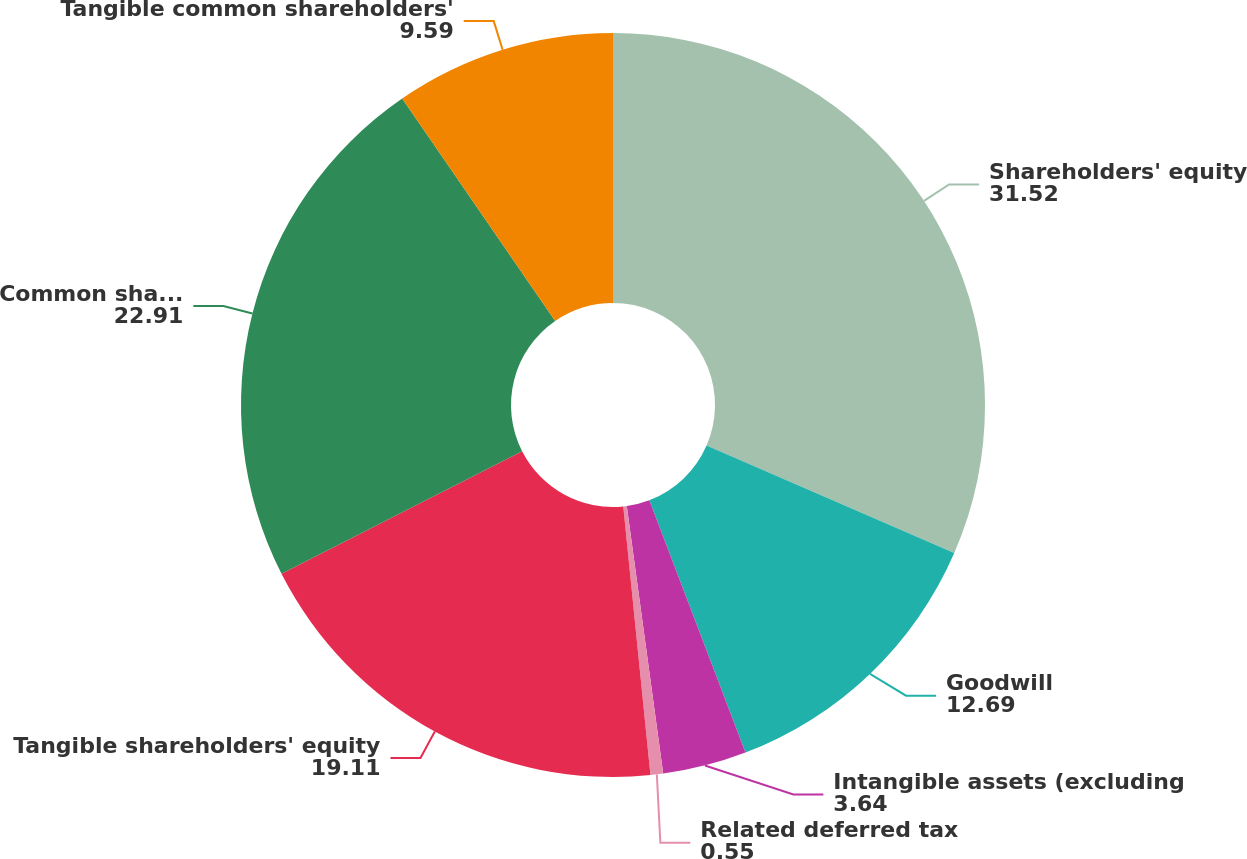<chart> <loc_0><loc_0><loc_500><loc_500><pie_chart><fcel>Shareholders' equity<fcel>Goodwill<fcel>Intangible assets (excluding<fcel>Related deferred tax<fcel>Tangible shareholders' equity<fcel>Common shareholders' equity<fcel>Tangible common shareholders'<nl><fcel>31.52%<fcel>12.69%<fcel>3.64%<fcel>0.55%<fcel>19.11%<fcel>22.91%<fcel>9.59%<nl></chart> 